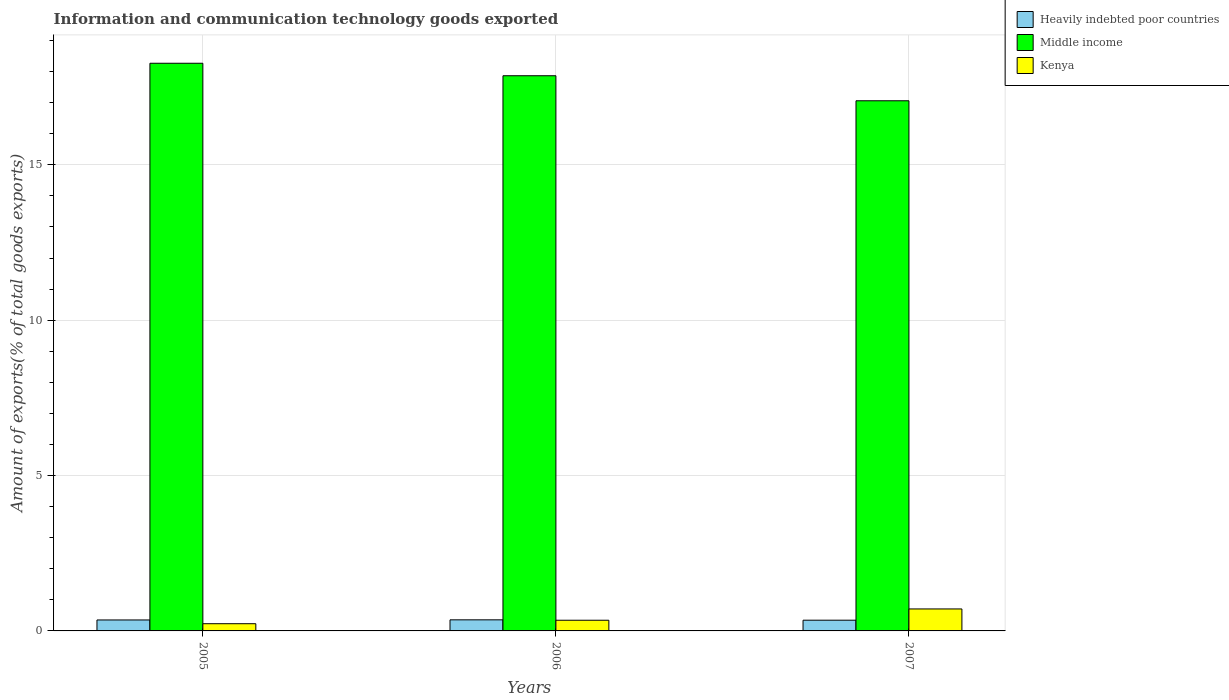How many different coloured bars are there?
Give a very brief answer. 3. Are the number of bars on each tick of the X-axis equal?
Keep it short and to the point. Yes. What is the amount of goods exported in Heavily indebted poor countries in 2005?
Provide a short and direct response. 0.35. Across all years, what is the maximum amount of goods exported in Middle income?
Your answer should be very brief. 18.27. Across all years, what is the minimum amount of goods exported in Heavily indebted poor countries?
Your response must be concise. 0.35. In which year was the amount of goods exported in Middle income maximum?
Make the answer very short. 2005. In which year was the amount of goods exported in Kenya minimum?
Ensure brevity in your answer.  2005. What is the total amount of goods exported in Heavily indebted poor countries in the graph?
Make the answer very short. 1.05. What is the difference between the amount of goods exported in Heavily indebted poor countries in 2005 and that in 2006?
Ensure brevity in your answer.  -0. What is the difference between the amount of goods exported in Heavily indebted poor countries in 2005 and the amount of goods exported in Kenya in 2006?
Provide a succinct answer. 0.01. What is the average amount of goods exported in Middle income per year?
Your response must be concise. 17.73. In the year 2007, what is the difference between the amount of goods exported in Middle income and amount of goods exported in Kenya?
Provide a succinct answer. 16.35. What is the ratio of the amount of goods exported in Heavily indebted poor countries in 2005 to that in 2007?
Make the answer very short. 1.02. Is the amount of goods exported in Middle income in 2005 less than that in 2007?
Provide a succinct answer. No. What is the difference between the highest and the second highest amount of goods exported in Middle income?
Offer a terse response. 0.4. What is the difference between the highest and the lowest amount of goods exported in Heavily indebted poor countries?
Provide a succinct answer. 0.01. Is the sum of the amount of goods exported in Heavily indebted poor countries in 2006 and 2007 greater than the maximum amount of goods exported in Middle income across all years?
Your answer should be very brief. No. What does the 3rd bar from the left in 2007 represents?
Offer a terse response. Kenya. What does the 1st bar from the right in 2005 represents?
Give a very brief answer. Kenya. How many bars are there?
Provide a short and direct response. 9. What is the difference between two consecutive major ticks on the Y-axis?
Your answer should be compact. 5. Does the graph contain any zero values?
Offer a very short reply. No. Does the graph contain grids?
Your answer should be very brief. Yes. How many legend labels are there?
Keep it short and to the point. 3. How are the legend labels stacked?
Your answer should be compact. Vertical. What is the title of the graph?
Offer a terse response. Information and communication technology goods exported. What is the label or title of the X-axis?
Make the answer very short. Years. What is the label or title of the Y-axis?
Keep it short and to the point. Amount of exports(% of total goods exports). What is the Amount of exports(% of total goods exports) in Heavily indebted poor countries in 2005?
Ensure brevity in your answer.  0.35. What is the Amount of exports(% of total goods exports) in Middle income in 2005?
Your response must be concise. 18.27. What is the Amount of exports(% of total goods exports) in Kenya in 2005?
Keep it short and to the point. 0.23. What is the Amount of exports(% of total goods exports) of Heavily indebted poor countries in 2006?
Provide a short and direct response. 0.36. What is the Amount of exports(% of total goods exports) in Middle income in 2006?
Provide a short and direct response. 17.86. What is the Amount of exports(% of total goods exports) of Kenya in 2006?
Your answer should be very brief. 0.34. What is the Amount of exports(% of total goods exports) of Heavily indebted poor countries in 2007?
Make the answer very short. 0.35. What is the Amount of exports(% of total goods exports) in Middle income in 2007?
Offer a very short reply. 17.06. What is the Amount of exports(% of total goods exports) in Kenya in 2007?
Keep it short and to the point. 0.71. Across all years, what is the maximum Amount of exports(% of total goods exports) of Heavily indebted poor countries?
Offer a terse response. 0.36. Across all years, what is the maximum Amount of exports(% of total goods exports) of Middle income?
Provide a short and direct response. 18.27. Across all years, what is the maximum Amount of exports(% of total goods exports) of Kenya?
Make the answer very short. 0.71. Across all years, what is the minimum Amount of exports(% of total goods exports) of Heavily indebted poor countries?
Your answer should be compact. 0.35. Across all years, what is the minimum Amount of exports(% of total goods exports) of Middle income?
Your answer should be compact. 17.06. Across all years, what is the minimum Amount of exports(% of total goods exports) in Kenya?
Keep it short and to the point. 0.23. What is the total Amount of exports(% of total goods exports) in Heavily indebted poor countries in the graph?
Make the answer very short. 1.05. What is the total Amount of exports(% of total goods exports) of Middle income in the graph?
Keep it short and to the point. 53.19. What is the total Amount of exports(% of total goods exports) of Kenya in the graph?
Your answer should be compact. 1.28. What is the difference between the Amount of exports(% of total goods exports) of Heavily indebted poor countries in 2005 and that in 2006?
Ensure brevity in your answer.  -0. What is the difference between the Amount of exports(% of total goods exports) of Middle income in 2005 and that in 2006?
Offer a terse response. 0.4. What is the difference between the Amount of exports(% of total goods exports) of Kenya in 2005 and that in 2006?
Make the answer very short. -0.11. What is the difference between the Amount of exports(% of total goods exports) in Heavily indebted poor countries in 2005 and that in 2007?
Offer a very short reply. 0.01. What is the difference between the Amount of exports(% of total goods exports) in Middle income in 2005 and that in 2007?
Keep it short and to the point. 1.21. What is the difference between the Amount of exports(% of total goods exports) in Kenya in 2005 and that in 2007?
Your answer should be very brief. -0.48. What is the difference between the Amount of exports(% of total goods exports) in Heavily indebted poor countries in 2006 and that in 2007?
Offer a very short reply. 0.01. What is the difference between the Amount of exports(% of total goods exports) in Middle income in 2006 and that in 2007?
Your answer should be compact. 0.81. What is the difference between the Amount of exports(% of total goods exports) of Kenya in 2006 and that in 2007?
Your response must be concise. -0.36. What is the difference between the Amount of exports(% of total goods exports) of Heavily indebted poor countries in 2005 and the Amount of exports(% of total goods exports) of Middle income in 2006?
Ensure brevity in your answer.  -17.51. What is the difference between the Amount of exports(% of total goods exports) in Heavily indebted poor countries in 2005 and the Amount of exports(% of total goods exports) in Kenya in 2006?
Your answer should be compact. 0.01. What is the difference between the Amount of exports(% of total goods exports) of Middle income in 2005 and the Amount of exports(% of total goods exports) of Kenya in 2006?
Provide a succinct answer. 17.92. What is the difference between the Amount of exports(% of total goods exports) in Heavily indebted poor countries in 2005 and the Amount of exports(% of total goods exports) in Middle income in 2007?
Give a very brief answer. -16.71. What is the difference between the Amount of exports(% of total goods exports) in Heavily indebted poor countries in 2005 and the Amount of exports(% of total goods exports) in Kenya in 2007?
Provide a short and direct response. -0.35. What is the difference between the Amount of exports(% of total goods exports) in Middle income in 2005 and the Amount of exports(% of total goods exports) in Kenya in 2007?
Your answer should be compact. 17.56. What is the difference between the Amount of exports(% of total goods exports) in Heavily indebted poor countries in 2006 and the Amount of exports(% of total goods exports) in Middle income in 2007?
Your response must be concise. -16.7. What is the difference between the Amount of exports(% of total goods exports) of Heavily indebted poor countries in 2006 and the Amount of exports(% of total goods exports) of Kenya in 2007?
Keep it short and to the point. -0.35. What is the difference between the Amount of exports(% of total goods exports) of Middle income in 2006 and the Amount of exports(% of total goods exports) of Kenya in 2007?
Provide a short and direct response. 17.16. What is the average Amount of exports(% of total goods exports) in Heavily indebted poor countries per year?
Your answer should be very brief. 0.35. What is the average Amount of exports(% of total goods exports) of Middle income per year?
Provide a short and direct response. 17.73. What is the average Amount of exports(% of total goods exports) of Kenya per year?
Make the answer very short. 0.43. In the year 2005, what is the difference between the Amount of exports(% of total goods exports) of Heavily indebted poor countries and Amount of exports(% of total goods exports) of Middle income?
Offer a very short reply. -17.91. In the year 2005, what is the difference between the Amount of exports(% of total goods exports) in Heavily indebted poor countries and Amount of exports(% of total goods exports) in Kenya?
Make the answer very short. 0.12. In the year 2005, what is the difference between the Amount of exports(% of total goods exports) in Middle income and Amount of exports(% of total goods exports) in Kenya?
Your answer should be very brief. 18.04. In the year 2006, what is the difference between the Amount of exports(% of total goods exports) in Heavily indebted poor countries and Amount of exports(% of total goods exports) in Middle income?
Provide a short and direct response. -17.51. In the year 2006, what is the difference between the Amount of exports(% of total goods exports) in Heavily indebted poor countries and Amount of exports(% of total goods exports) in Kenya?
Offer a very short reply. 0.01. In the year 2006, what is the difference between the Amount of exports(% of total goods exports) of Middle income and Amount of exports(% of total goods exports) of Kenya?
Make the answer very short. 17.52. In the year 2007, what is the difference between the Amount of exports(% of total goods exports) in Heavily indebted poor countries and Amount of exports(% of total goods exports) in Middle income?
Offer a very short reply. -16.71. In the year 2007, what is the difference between the Amount of exports(% of total goods exports) in Heavily indebted poor countries and Amount of exports(% of total goods exports) in Kenya?
Ensure brevity in your answer.  -0.36. In the year 2007, what is the difference between the Amount of exports(% of total goods exports) in Middle income and Amount of exports(% of total goods exports) in Kenya?
Provide a succinct answer. 16.35. What is the ratio of the Amount of exports(% of total goods exports) of Middle income in 2005 to that in 2006?
Ensure brevity in your answer.  1.02. What is the ratio of the Amount of exports(% of total goods exports) of Kenya in 2005 to that in 2006?
Make the answer very short. 0.67. What is the ratio of the Amount of exports(% of total goods exports) of Heavily indebted poor countries in 2005 to that in 2007?
Keep it short and to the point. 1.02. What is the ratio of the Amount of exports(% of total goods exports) in Middle income in 2005 to that in 2007?
Ensure brevity in your answer.  1.07. What is the ratio of the Amount of exports(% of total goods exports) of Kenya in 2005 to that in 2007?
Your answer should be compact. 0.33. What is the ratio of the Amount of exports(% of total goods exports) in Heavily indebted poor countries in 2006 to that in 2007?
Provide a succinct answer. 1.03. What is the ratio of the Amount of exports(% of total goods exports) in Middle income in 2006 to that in 2007?
Your response must be concise. 1.05. What is the ratio of the Amount of exports(% of total goods exports) in Kenya in 2006 to that in 2007?
Give a very brief answer. 0.49. What is the difference between the highest and the second highest Amount of exports(% of total goods exports) of Heavily indebted poor countries?
Your response must be concise. 0. What is the difference between the highest and the second highest Amount of exports(% of total goods exports) in Middle income?
Offer a very short reply. 0.4. What is the difference between the highest and the second highest Amount of exports(% of total goods exports) in Kenya?
Your answer should be compact. 0.36. What is the difference between the highest and the lowest Amount of exports(% of total goods exports) in Heavily indebted poor countries?
Give a very brief answer. 0.01. What is the difference between the highest and the lowest Amount of exports(% of total goods exports) in Middle income?
Offer a terse response. 1.21. What is the difference between the highest and the lowest Amount of exports(% of total goods exports) of Kenya?
Ensure brevity in your answer.  0.48. 